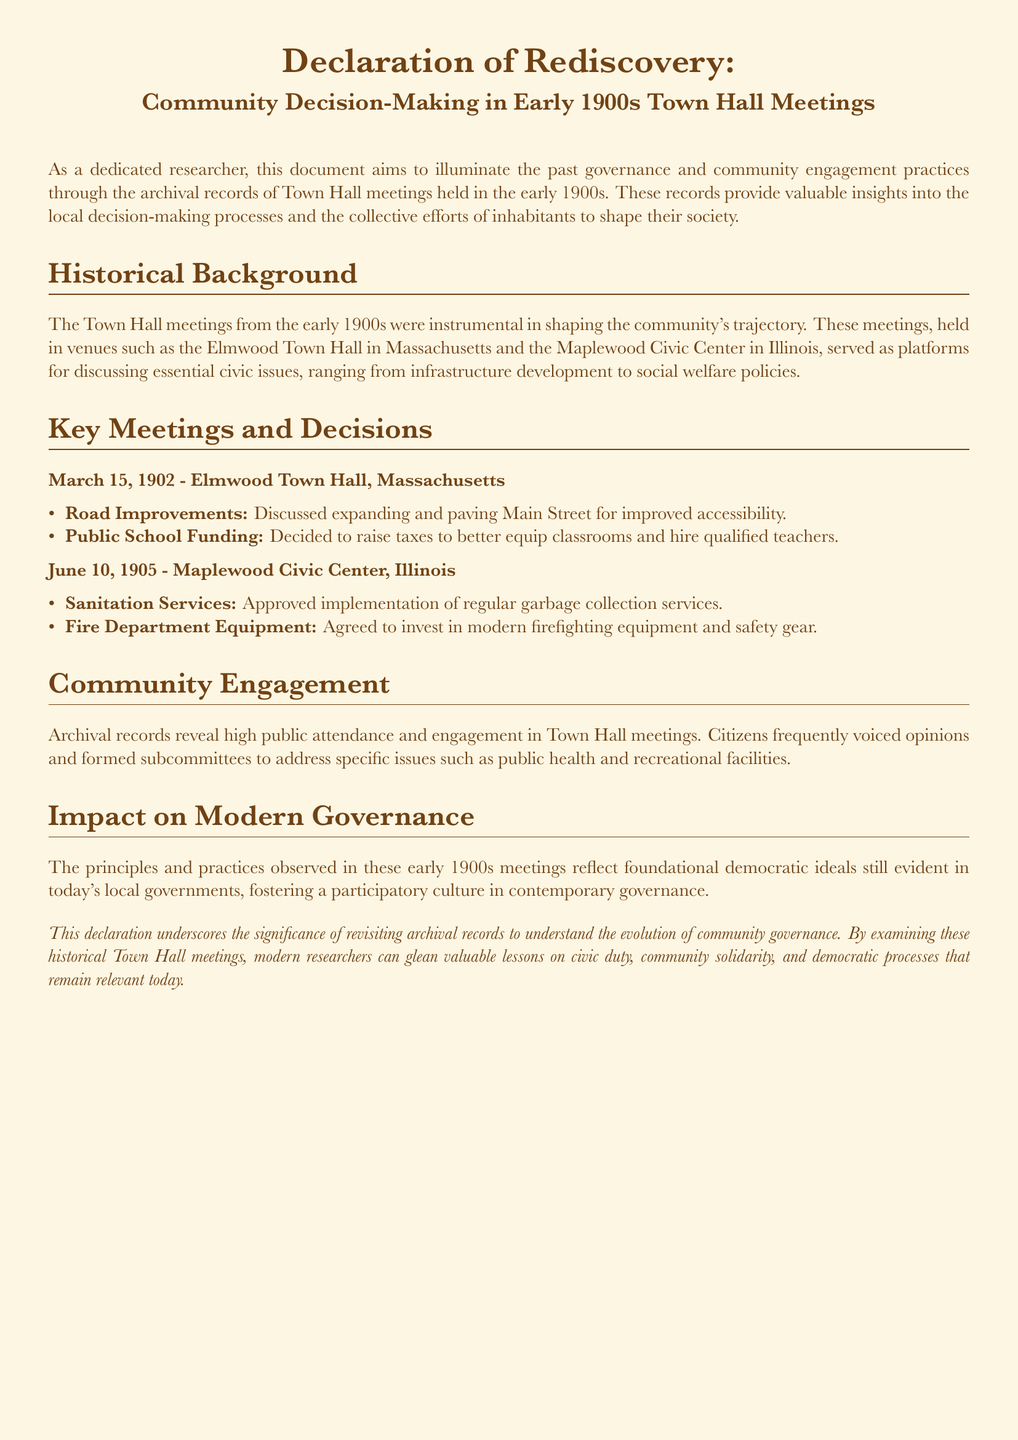what is the date of the meeting discussed in Elmwood Town Hall? The document specifies a meeting date of March 15, 1902.
Answer: March 15, 1902 what was discussed at the June 10, 1905 meeting? The document lists sanitation services and fire department equipment as topics of discussion.
Answer: Sanitation services and fire department equipment which town hall is mentioned in Massachusetts? The document explicitly states Elmwood Town Hall as the location in Massachusetts.
Answer: Elmwood Town Hall what key decision was made regarding public schools? The document notes a decision to raise taxes to better equip classrooms and hire qualified teachers.
Answer: Raise taxes how did community engagement manifest in Town Hall meetings? The document indicates high public attendance and the formation of subcommittees.
Answer: High public attendance and formation of subcommittees what principle is highlighted in the impact on modern governance section? The document emphasizes the principles of foundational democratic ideals in local governments.
Answer: Foundational democratic ideals how frequently did citizens voice their opinions? The document states that citizens frequently voiced opinions during the meetings.
Answer: Frequently what is the purpose of this declaration? The document aims to illuminate past governance and community engagement practices through archival records.
Answer: Illuminate past governance and community engagement practices 